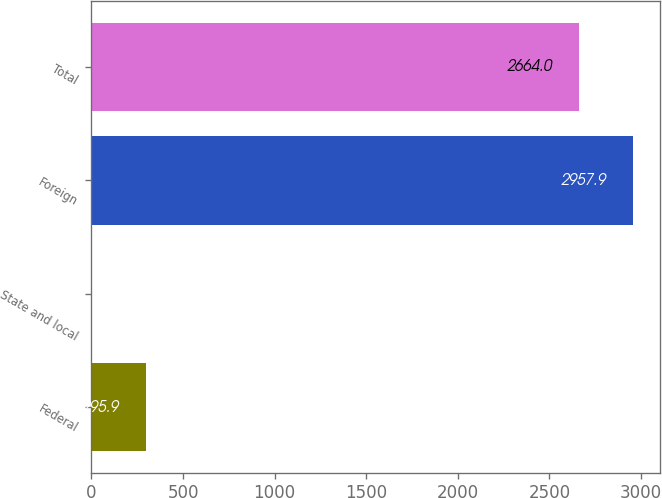<chart> <loc_0><loc_0><loc_500><loc_500><bar_chart><fcel>Federal<fcel>State and local<fcel>Foreign<fcel>Total<nl><fcel>295.9<fcel>2<fcel>2957.9<fcel>2664<nl></chart> 